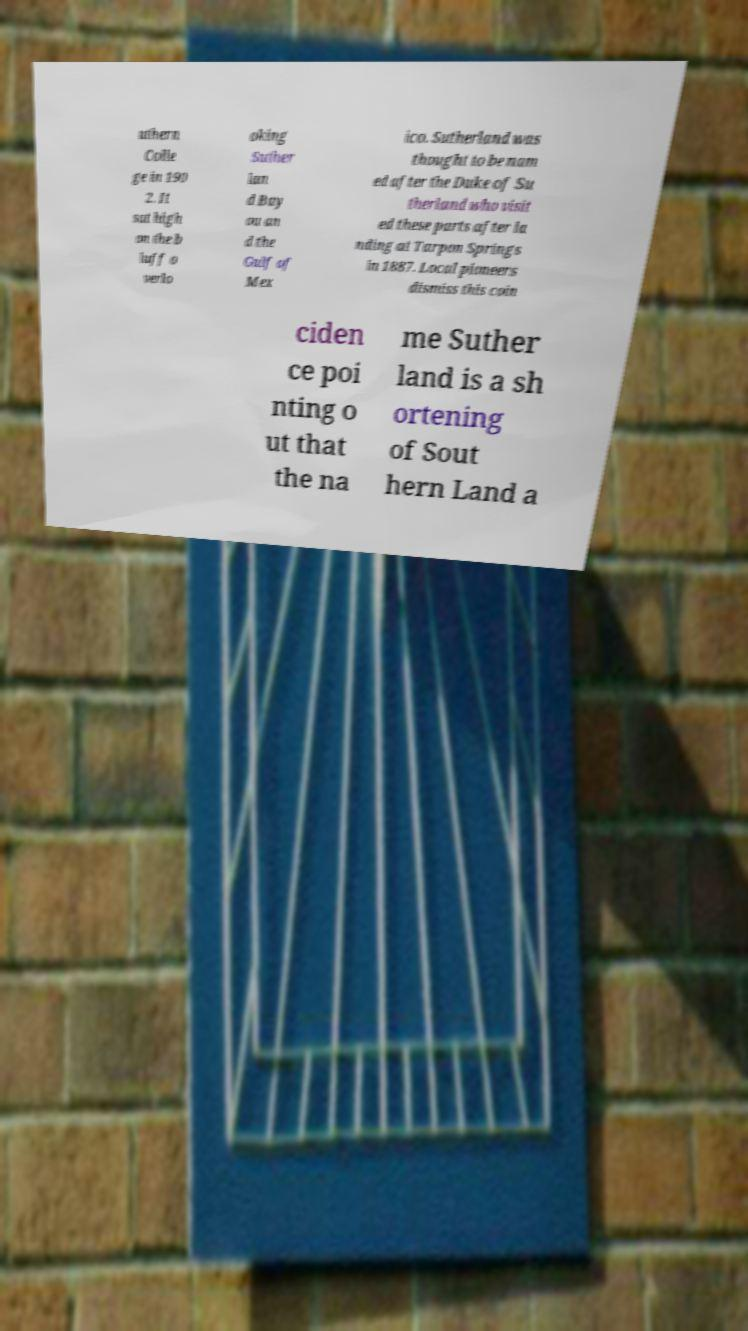What messages or text are displayed in this image? I need them in a readable, typed format. uthern Colle ge in 190 2. It sat high on the b luff o verlo oking Suther lan d Bay ou an d the Gulf of Mex ico. Sutherland was thought to be nam ed after the Duke of Su therland who visit ed these parts after la nding at Tarpon Springs in 1887. Local pioneers dismiss this coin ciden ce poi nting o ut that the na me Suther land is a sh ortening of Sout hern Land a 